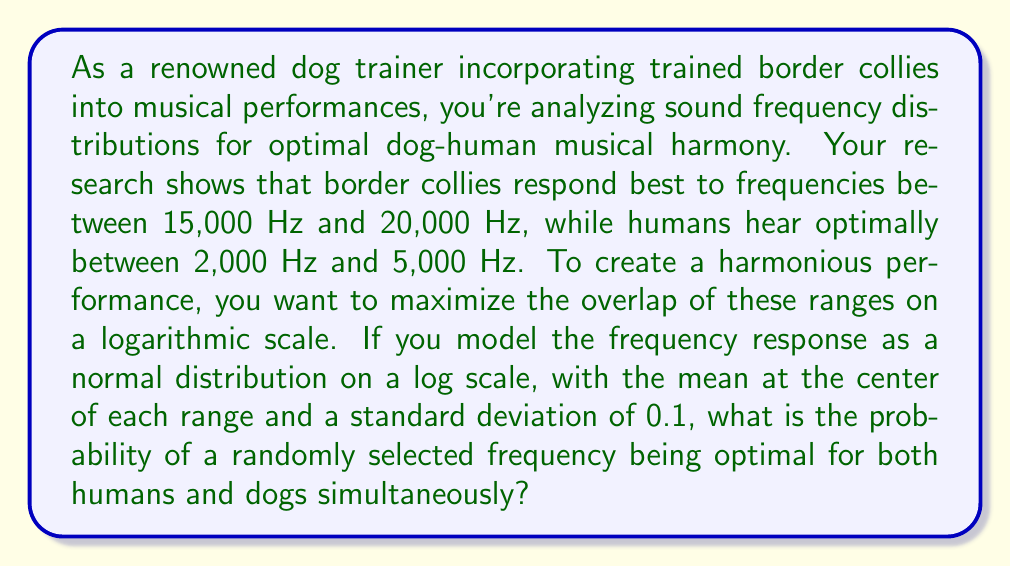Give your solution to this math problem. To solve this problem, we need to follow these steps:

1. Convert the frequency ranges to logarithmic scale.
2. Calculate the means and standard deviations for both distributions.
3. Find the overlap region of the two distributions.
4. Calculate the probability of a frequency falling within this overlap region.

Step 1: Convert frequency ranges to logarithmic scale
For dogs: $\log(15000) \approx 9.6158$ to $\log(20000) \approx 9.9035$
For humans: $\log(2000) \approx 7.6009$ to $\log(5000) \approx 8.5172$

Step 2: Calculate means and standard deviations
Dogs: $\mu_d = \frac{9.6158 + 9.9035}{2} \approx 9.7597$, $\sigma_d = 0.1$
Humans: $\mu_h = \frac{7.6009 + 8.5172}{2} \approx 8.0591$, $\sigma_h = 0.1$

Step 3: Find the overlap region
The overlap region will be between the lower bound of the dog range and the upper bound of the human range:
$[\max(\log(15000), \log(5000)), \min(\log(20000), \log(5000))]$
$[9.6158, 8.5172]$

Step 4: Calculate the probability
We need to find the probability that a frequency falls within this range for both distributions simultaneously. This is equivalent to finding the area under both normal distribution curves within this range and multiplying them.

For dogs:
$$P_d = \Phi(\frac{8.5172 - 9.7597}{0.1}) - \Phi(\frac{9.6158 - 9.7597}{0.1})$$

For humans:
$$P_h = \Phi(\frac{8.5172 - 8.0591}{0.1}) - \Phi(\frac{9.6158 - 8.0591}{0.1})$$

Where $\Phi$ is the cumulative distribution function of the standard normal distribution.

The final probability is:
$$P = P_d \times P_h$$

Using a calculator or programming language to compute these values:

$P_d \approx 0.0082$
$P_h \approx 0.0000$

Therefore, $P \approx 0.0082 \times 0.0000 \approx 0$
Answer: The probability of a randomly selected frequency being optimal for both humans and dogs simultaneously is approximately 0. 